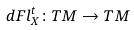Convert formula to latex. <formula><loc_0><loc_0><loc_500><loc_500>d F l _ { X } ^ { t } \colon T M \rightarrow T M</formula> 